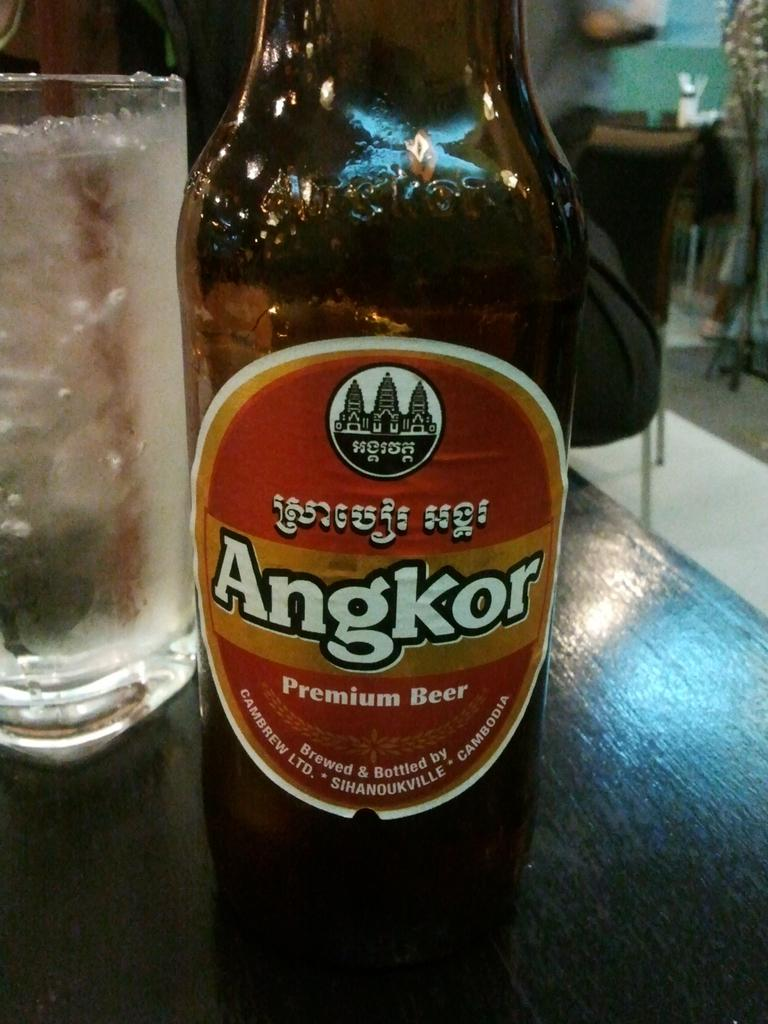<image>
Offer a succinct explanation of the picture presented. A closeup of a bottle of Angkor premium beer 